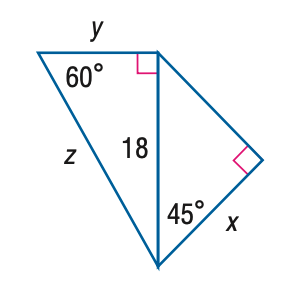Answer the mathemtical geometry problem and directly provide the correct option letter.
Question: Find x.
Choices: A: 9 B: 9 \sqrt { 2 } C: 9 \sqrt { 3 } D: 18 \sqrt { 2 } B 